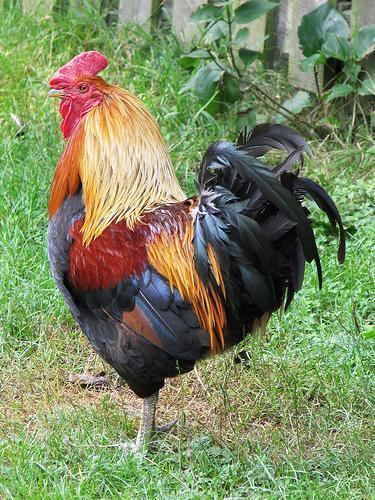How many roosters are pictured?
Give a very brief answer. 1. 